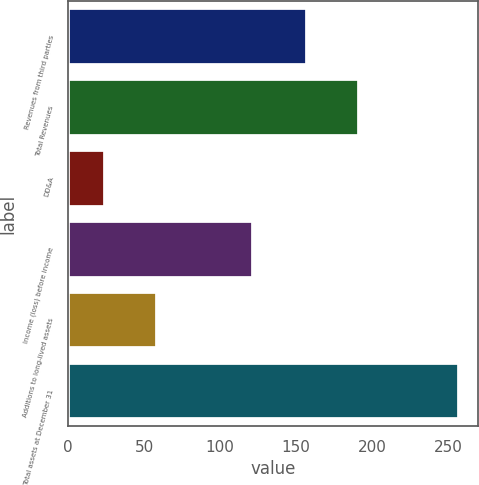Convert chart. <chart><loc_0><loc_0><loc_500><loc_500><bar_chart><fcel>Revenues from third parties<fcel>Total Revenues<fcel>DD&A<fcel>Income (loss) before income<fcel>Additions to long-lived assets<fcel>Total assets at December 31<nl><fcel>157<fcel>191.2<fcel>24<fcel>122<fcel>58.2<fcel>257<nl></chart> 